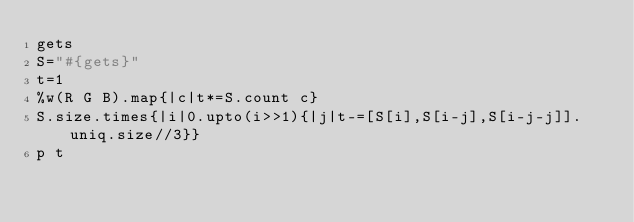Convert code to text. <code><loc_0><loc_0><loc_500><loc_500><_Crystal_>gets
S="#{gets}"
t=1
%w(R G B).map{|c|t*=S.count c}
S.size.times{|i|0.upto(i>>1){|j|t-=[S[i],S[i-j],S[i-j-j]].uniq.size//3}}
p t</code> 